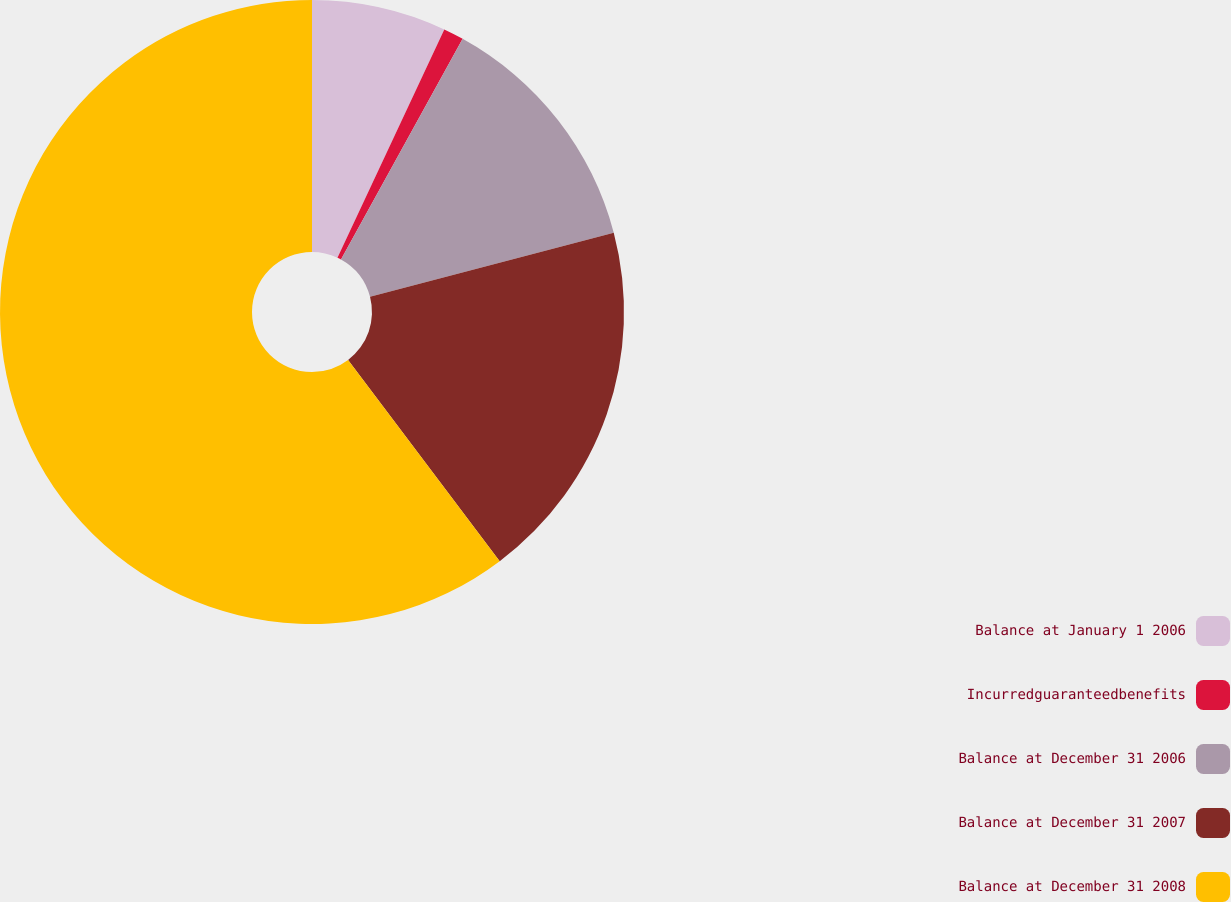Convert chart to OTSL. <chart><loc_0><loc_0><loc_500><loc_500><pie_chart><fcel>Balance at January 1 2006<fcel>Incurredguaranteedbenefits<fcel>Balance at December 31 2006<fcel>Balance at December 31 2007<fcel>Balance at December 31 2008<nl><fcel>6.97%<fcel>1.05%<fcel>12.89%<fcel>18.82%<fcel>60.28%<nl></chart> 